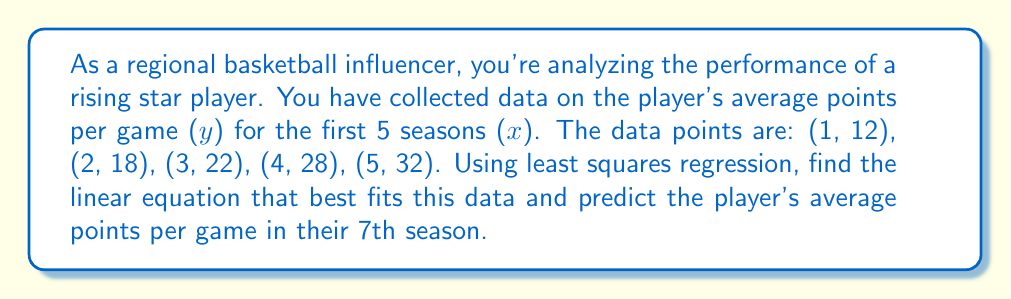Teach me how to tackle this problem. 1) For linear regression, we use the formula $y = mx + b$, where $m$ is the slope and $b$ is the y-intercept.

2) To find $m$ and $b$, we use these formulas:

   $m = \frac{n\sum xy - \sum x \sum y}{n\sum x^2 - (\sum x)^2}$

   $b = \frac{\sum y - m\sum x}{n}$

   where $n$ is the number of data points.

3) Calculate the sums:
   $n = 5$
   $\sum x = 1 + 2 + 3 + 4 + 5 = 15$
   $\sum y = 12 + 18 + 22 + 28 + 32 = 112$
   $\sum xy = 1(12) + 2(18) + 3(22) + 4(28) + 5(32) = 446$
   $\sum x^2 = 1^2 + 2^2 + 3^2 + 4^2 + 5^2 = 55$

4) Calculate $m$:
   $m = \frac{5(446) - 15(112)}{5(55) - 15^2} = \frac{2230 - 1680}{275 - 225} = \frac{550}{50} = 11$

5) Calculate $b$:
   $b = \frac{112 - 11(15)}{5} = \frac{112 - 165}{5} = -10.6$

6) The linear regression equation is:
   $y = 11x - 10.6$

7) To predict the average points for the 7th season, substitute $x = 7$:
   $y = 11(7) - 10.6 = 77 - 10.6 = 66.4$
Answer: $y = 11x - 10.6$; 66.4 points 